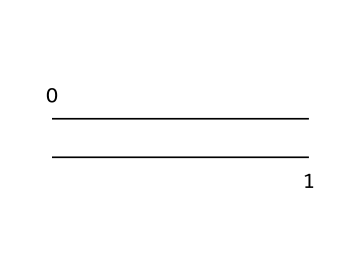What is the molecular formula of ethylene? Ethylene consists of two carbon atoms and four hydrogen atoms, which can be summed up to give the molecular formula C2H4.
Answer: C2H4 How many double bonds are present in ethylene? The structure shows a double bond between the two carbon atoms, which is characteristic of alkenes like ethylene. Therefore, there is one double bond in ethylene.
Answer: 1 What is the hybridization of the carbon atoms in ethylene? The carbon atoms in ethylene are sp2 hybridized, which means one s orbital and two p orbitals combine to form three sp2 hybrid orbitals, allowing for the trigonal planar shape and the formation of a double bond.
Answer: sp2 What type of reaction does ethylene commonly undergo? Ethylene is known for participating in addition reactions due to its double bond, allowing other molecules to add across this bond, making it prominent in polymerization processes.
Answer: addition Is ethylene a saturated or unsaturated compound? Ethylene is classified as an unsaturated compound because of its double bond, indicating that it does not contain the maximum number of hydrogen atoms that could be bonded to the carbon atoms in a saturated hydrocarbon.
Answer: unsaturated How many hydrogen atoms are directly bonded to each carbon in ethylene? Each carbon atom in ethylene is bonded to two hydrogen atoms, as seen in its structure (C2H4), with two bonds made by each carbon atom.
Answer: 2 What kind of polymer is formed from ethylene? Ethylene polymerizes through addition reactions to form polyethylene, a widely used polymer in various applications, including packaging and containers.
Answer: polyethylene 